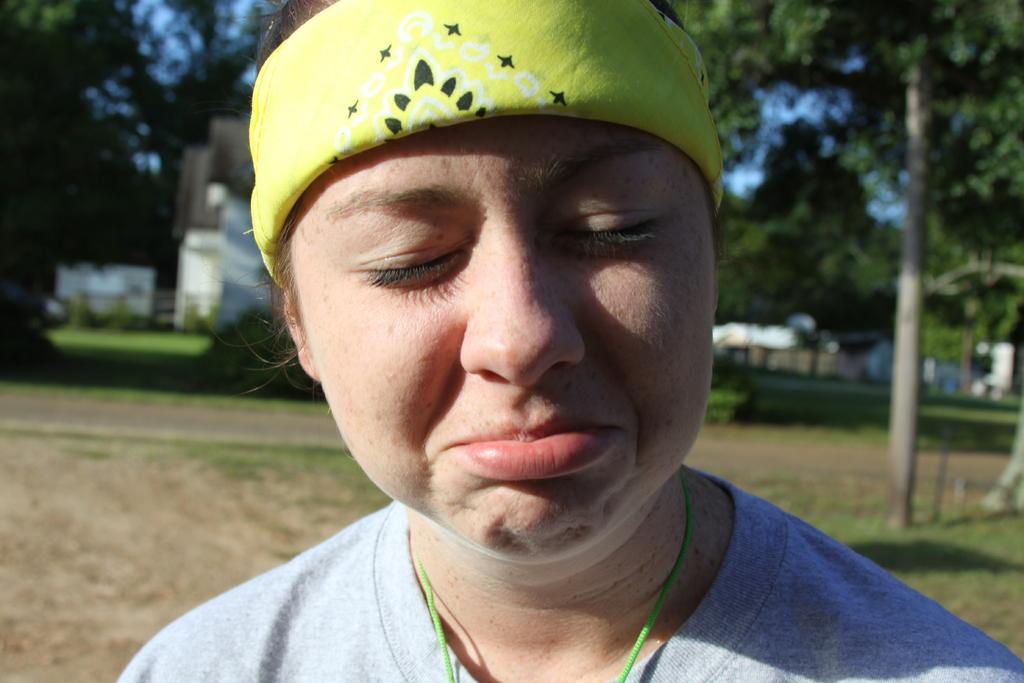Can you describe this image briefly? In the picture I can see a woman. In the background I can see trees, the sky and some other objects. The background of the image is blurred. 